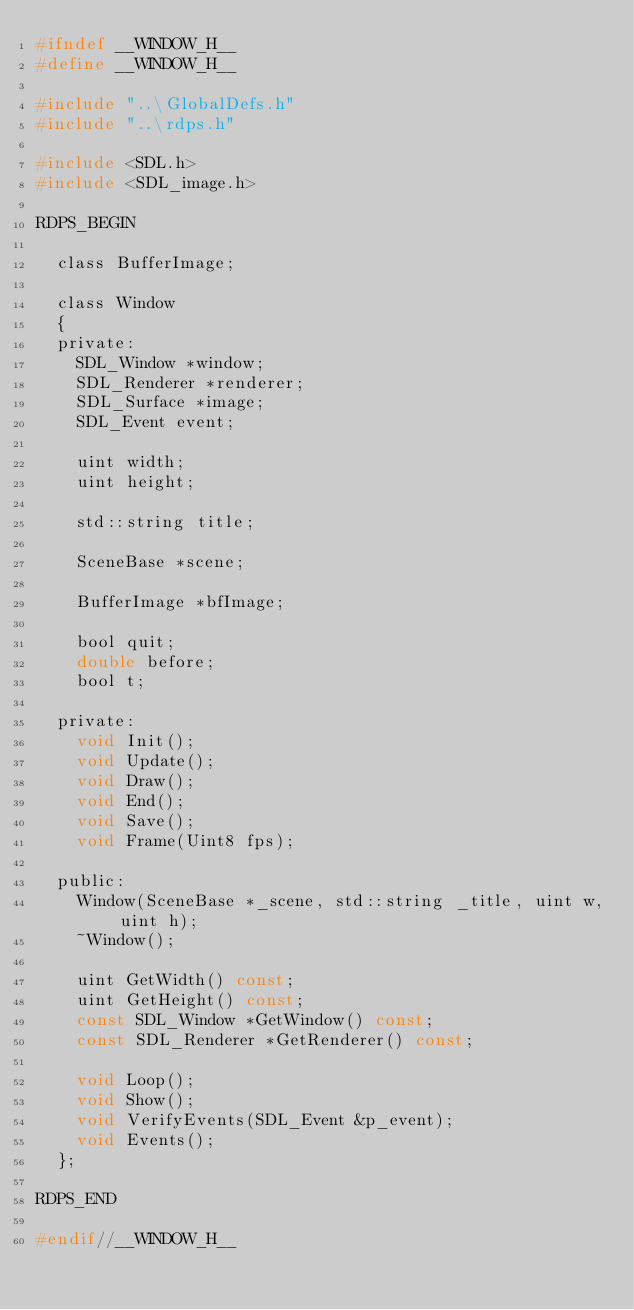Convert code to text. <code><loc_0><loc_0><loc_500><loc_500><_C_>#ifndef	__WINDOW_H__
#define	__WINDOW_H__

#include "..\GlobalDefs.h"
#include "..\rdps.h"

#include <SDL.h>
#include <SDL_image.h>

RDPS_BEGIN
	
	class BufferImage;

	class Window
	{
	private:
		SDL_Window *window;
		SDL_Renderer *renderer;
		SDL_Surface *image;
		SDL_Event event;

		uint width;
		uint height;

		std::string title;

		SceneBase *scene;

		BufferImage *bfImage;

		bool quit;
		double before;
		bool t;

	private:
		void Init();
		void Update();
		void Draw();
		void End();
		void Save();
		void Frame(Uint8 fps);

	public:
		Window(SceneBase *_scene, std::string _title, uint w, uint h);
		~Window();

		uint GetWidth() const;
		uint GetHeight() const;
		const SDL_Window *GetWindow() const;
		const SDL_Renderer *GetRenderer() const;

		void Loop();
		void Show();
		void VerifyEvents(SDL_Event &p_event);
		void Events();
	};

RDPS_END

#endif//__WINDOW_H__</code> 